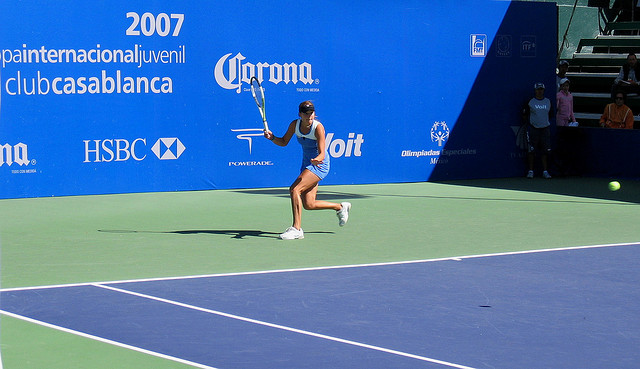Please extract the text content from this image. 2007 ernacional juvenil casablanca HSBC paint Club na Voit Corona 